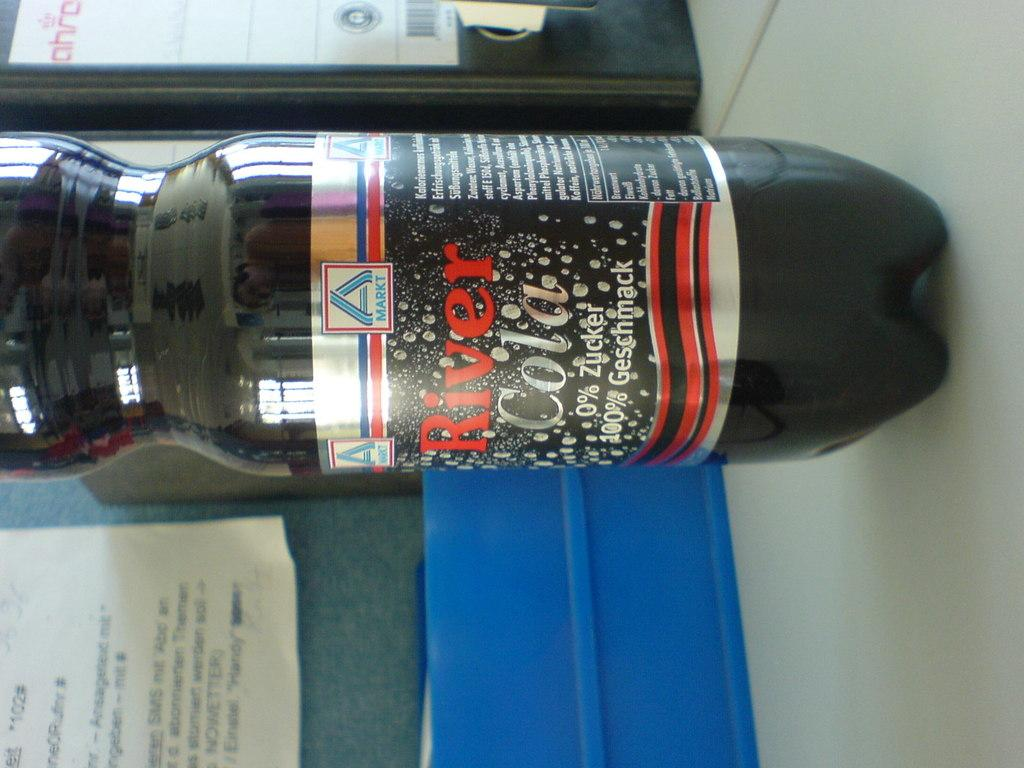Provide a one-sentence caption for the provided image. A bottle of River Cola is sitting on light colored surface. 